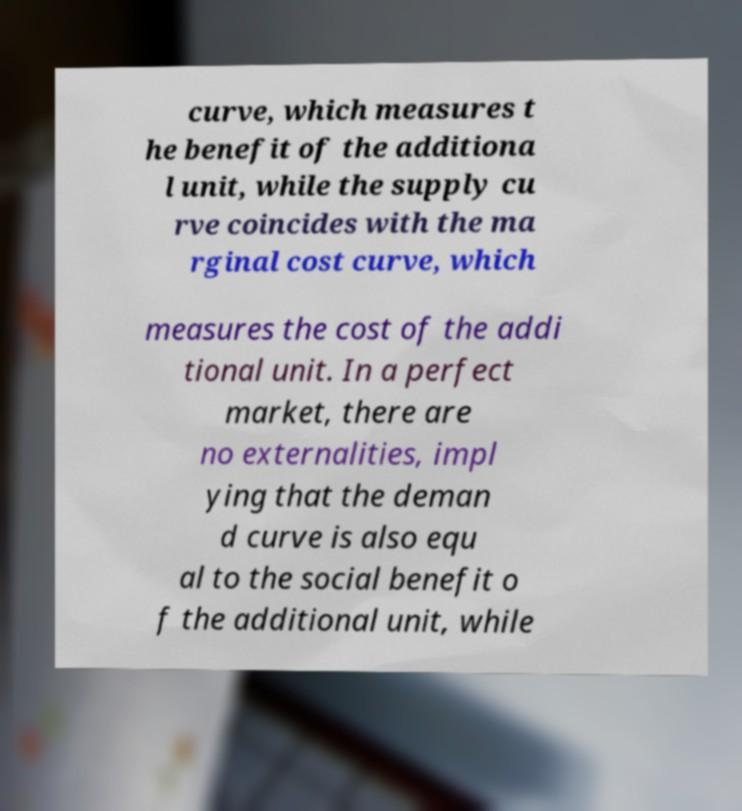Could you assist in decoding the text presented in this image and type it out clearly? curve, which measures t he benefit of the additiona l unit, while the supply cu rve coincides with the ma rginal cost curve, which measures the cost of the addi tional unit. In a perfect market, there are no externalities, impl ying that the deman d curve is also equ al to the social benefit o f the additional unit, while 